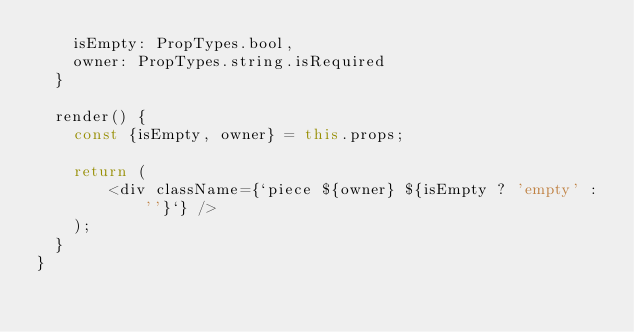Convert code to text. <code><loc_0><loc_0><loc_500><loc_500><_JavaScript_>    isEmpty: PropTypes.bool,
    owner: PropTypes.string.isRequired
  }

  render() {
    const {isEmpty, owner} = this.props;

    return (
        <div className={`piece ${owner} ${isEmpty ? 'empty' : ''}`} />
    );
  }
}
</code> 